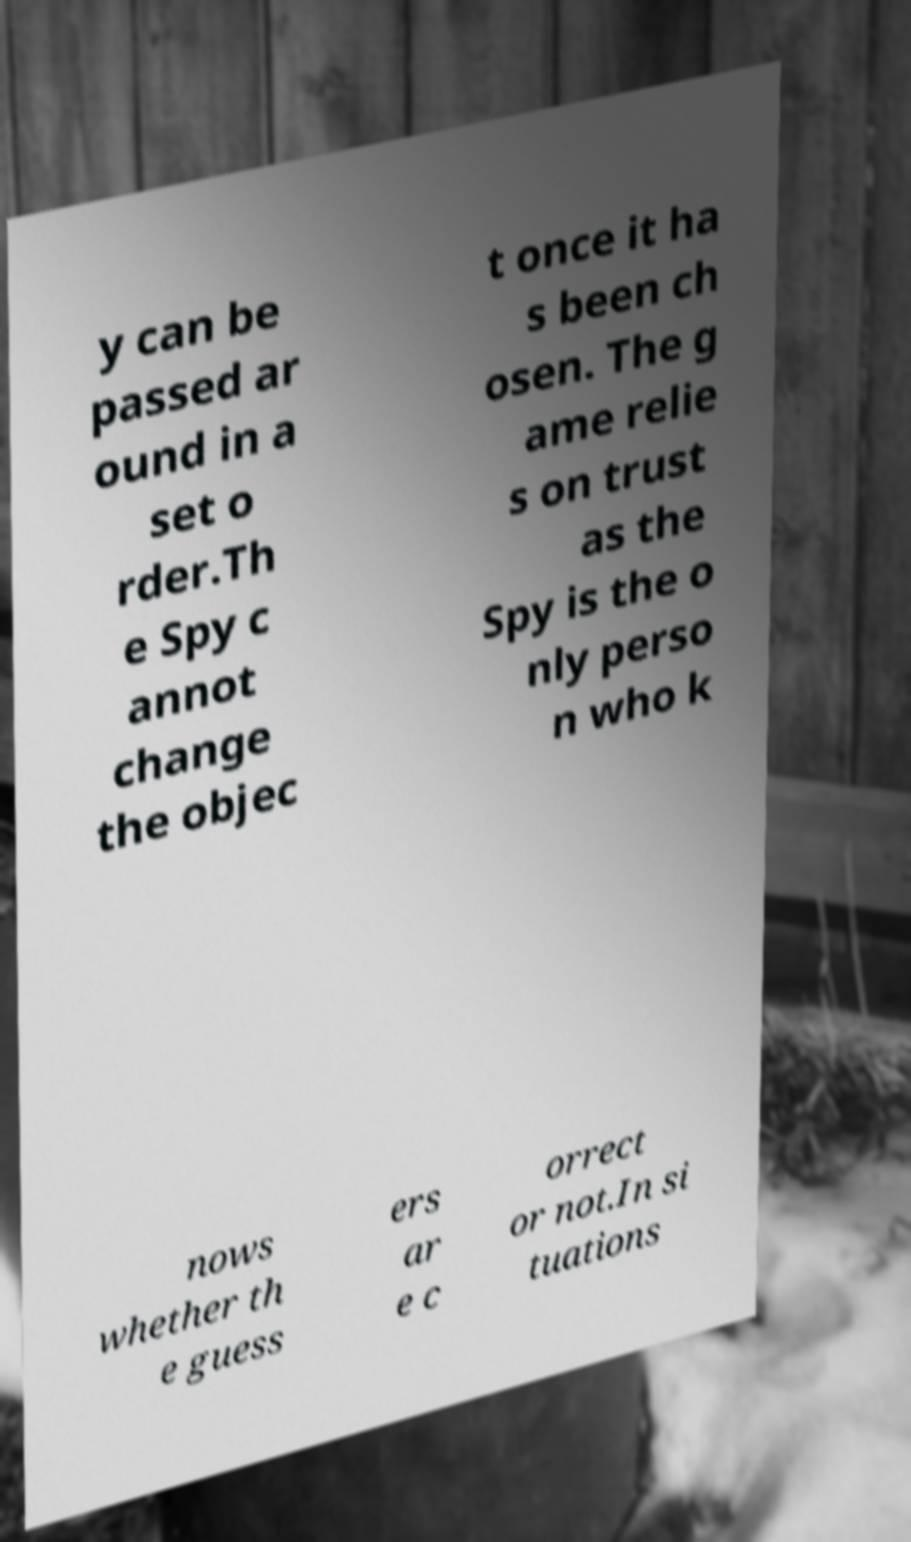Please identify and transcribe the text found in this image. y can be passed ar ound in a set o rder.Th e Spy c annot change the objec t once it ha s been ch osen. The g ame relie s on trust as the Spy is the o nly perso n who k nows whether th e guess ers ar e c orrect or not.In si tuations 